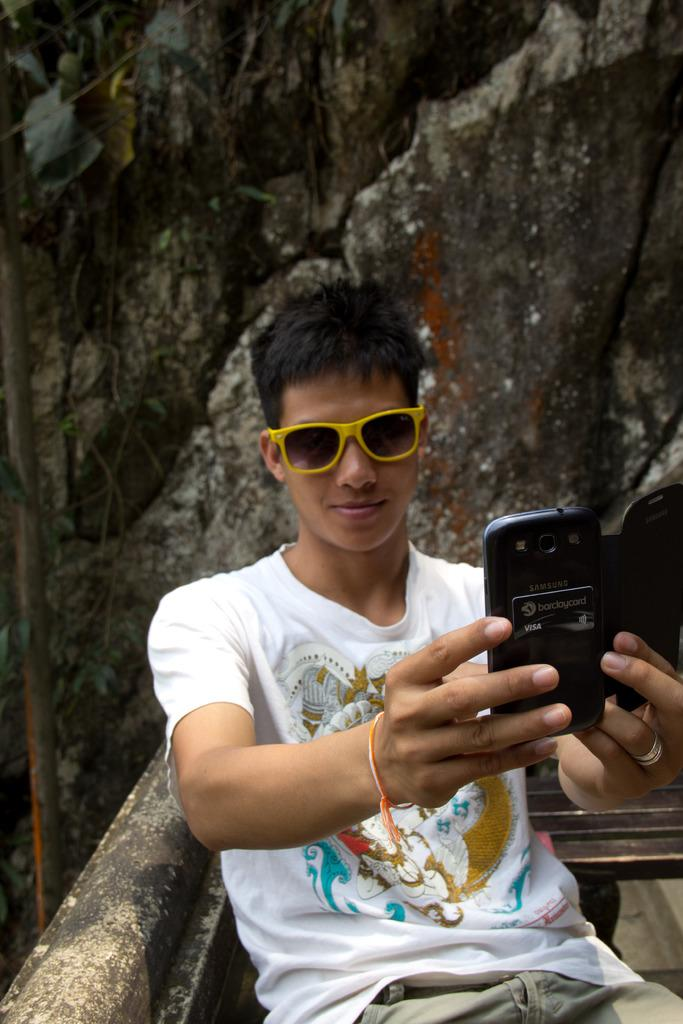Who is the main subject in the image? There is a boy in the image. What is the boy doing in the image? The boy is sitting on a bench. What is the boy holding in his hand? The boy is holding a mobile phone in his hand. What accessory is the boy wearing? The boy is wearing spectacles. What type of natural elements can be seen behind the boy? There are rocks behind the boy. What can be seen in the top left corner of the image? Leaves are visible in the top left corner of the image. What type of engine can be seen in the image? There is no engine present in the image. What type of competition is the boy participating in? There is no competition present in the image. 